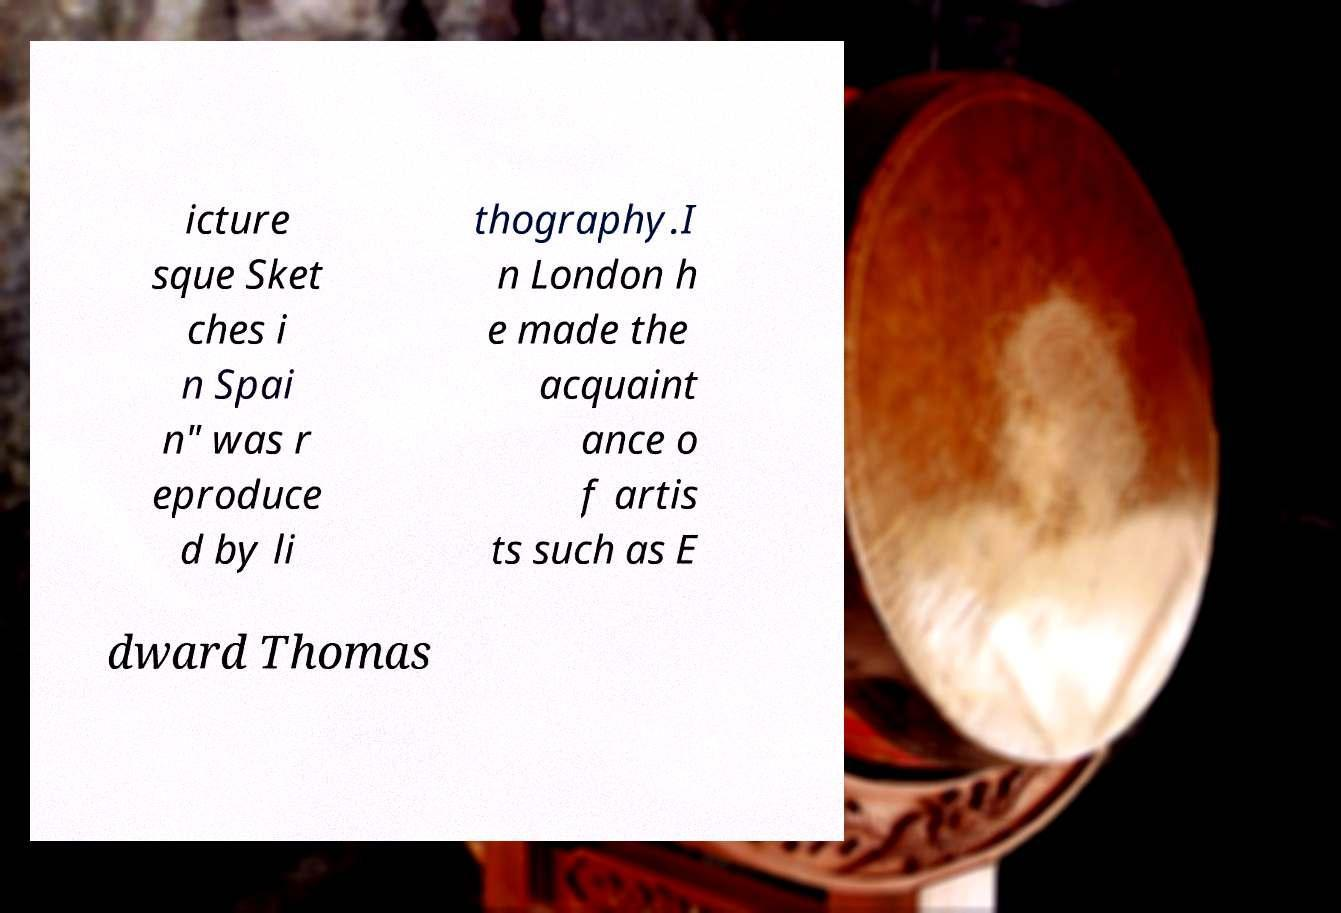Can you read and provide the text displayed in the image?This photo seems to have some interesting text. Can you extract and type it out for me? icture sque Sket ches i n Spai n" was r eproduce d by li thography.I n London h e made the acquaint ance o f artis ts such as E dward Thomas 